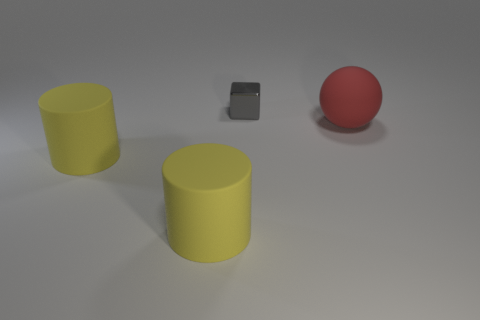The red object has what size?
Provide a succinct answer. Large. There is a thing that is behind the object that is to the right of the gray block; what color is it?
Your answer should be compact. Gray. What number of things are on the left side of the large red rubber thing and in front of the shiny object?
Make the answer very short. 2. Is the number of big things greater than the number of tiny metal cubes?
Ensure brevity in your answer.  Yes. What material is the red sphere?
Ensure brevity in your answer.  Rubber. There is a big object that is right of the gray metallic cube; what number of objects are to the right of it?
Your answer should be compact. 0. There is a block; does it have the same color as the big matte object that is right of the gray metallic thing?
Give a very brief answer. No. Is there a yellow rubber thing of the same shape as the large red object?
Offer a terse response. No. Is the number of gray metal things less than the number of cyan matte cylinders?
Provide a succinct answer. No. What is the color of the thing that is right of the metallic block?
Your answer should be very brief. Red. 